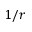<formula> <loc_0><loc_0><loc_500><loc_500>1 / r</formula> 